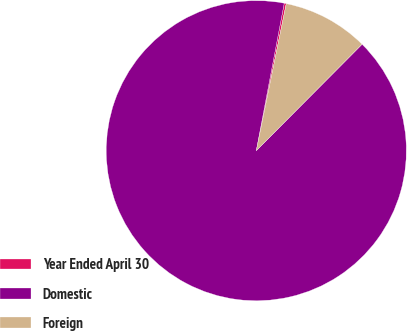Convert chart to OTSL. <chart><loc_0><loc_0><loc_500><loc_500><pie_chart><fcel>Year Ended April 30<fcel>Domestic<fcel>Foreign<nl><fcel>0.22%<fcel>90.52%<fcel>9.25%<nl></chart> 